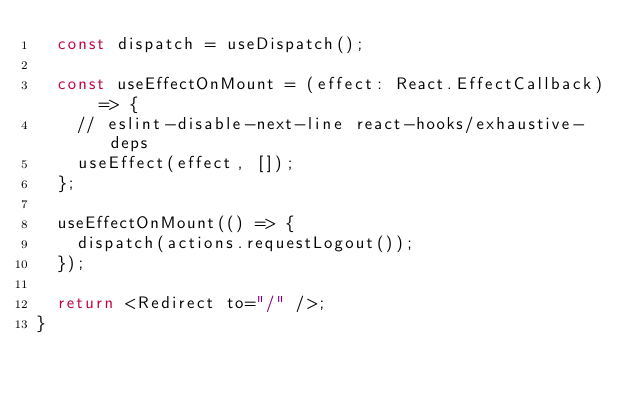Convert code to text. <code><loc_0><loc_0><loc_500><loc_500><_TypeScript_>  const dispatch = useDispatch();

  const useEffectOnMount = (effect: React.EffectCallback) => {
    // eslint-disable-next-line react-hooks/exhaustive-deps
    useEffect(effect, []);
  };

  useEffectOnMount(() => {
    dispatch(actions.requestLogout());
  });

  return <Redirect to="/" />;
}
</code> 